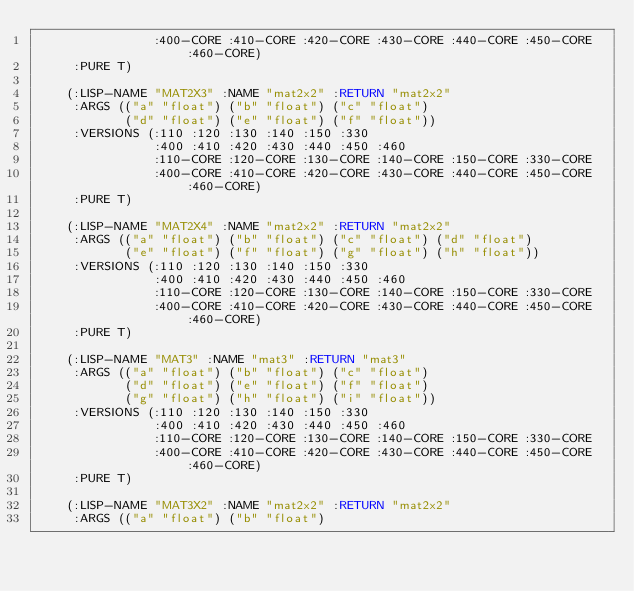<code> <loc_0><loc_0><loc_500><loc_500><_Lisp_>                :400-CORE :410-CORE :420-CORE :430-CORE :440-CORE :450-CORE :460-CORE)
     :PURE T)

    (:LISP-NAME "MAT2X3" :NAME "mat2x2" :RETURN "mat2x2"
     :ARGS (("a" "float") ("b" "float") ("c" "float")
            ("d" "float") ("e" "float") ("f" "float"))
     :VERSIONS (:110 :120 :130 :140 :150 :330
                :400 :410 :420 :430 :440 :450 :460
                :110-CORE :120-CORE :130-CORE :140-CORE :150-CORE :330-CORE
                :400-CORE :410-CORE :420-CORE :430-CORE :440-CORE :450-CORE :460-CORE)
     :PURE T)

    (:LISP-NAME "MAT2X4" :NAME "mat2x2" :RETURN "mat2x2"
     :ARGS (("a" "float") ("b" "float") ("c" "float") ("d" "float")
            ("e" "float") ("f" "float") ("g" "float") ("h" "float"))
     :VERSIONS (:110 :120 :130 :140 :150 :330
                :400 :410 :420 :430 :440 :450 :460
                :110-CORE :120-CORE :130-CORE :140-CORE :150-CORE :330-CORE
                :400-CORE :410-CORE :420-CORE :430-CORE :440-CORE :450-CORE :460-CORE)
     :PURE T)

    (:LISP-NAME "MAT3" :NAME "mat3" :RETURN "mat3"
     :ARGS (("a" "float") ("b" "float") ("c" "float")
            ("d" "float") ("e" "float") ("f" "float")
            ("g" "float") ("h" "float") ("i" "float"))
     :VERSIONS (:110 :120 :130 :140 :150 :330
                :400 :410 :420 :430 :440 :450 :460
                :110-CORE :120-CORE :130-CORE :140-CORE :150-CORE :330-CORE
                :400-CORE :410-CORE :420-CORE :430-CORE :440-CORE :450-CORE :460-CORE)
     :PURE T)

    (:LISP-NAME "MAT3X2" :NAME "mat2x2" :RETURN "mat2x2"
     :ARGS (("a" "float") ("b" "float")</code> 